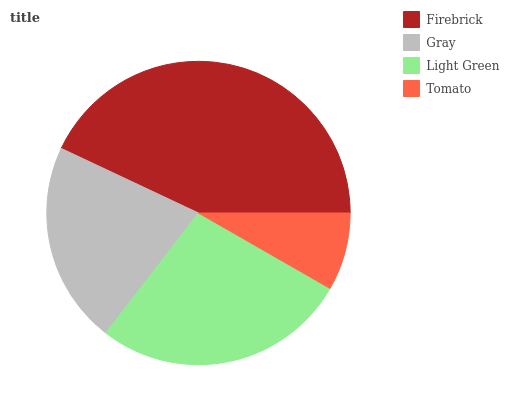Is Tomato the minimum?
Answer yes or no. Yes. Is Firebrick the maximum?
Answer yes or no. Yes. Is Gray the minimum?
Answer yes or no. No. Is Gray the maximum?
Answer yes or no. No. Is Firebrick greater than Gray?
Answer yes or no. Yes. Is Gray less than Firebrick?
Answer yes or no. Yes. Is Gray greater than Firebrick?
Answer yes or no. No. Is Firebrick less than Gray?
Answer yes or no. No. Is Light Green the high median?
Answer yes or no. Yes. Is Gray the low median?
Answer yes or no. Yes. Is Firebrick the high median?
Answer yes or no. No. Is Firebrick the low median?
Answer yes or no. No. 